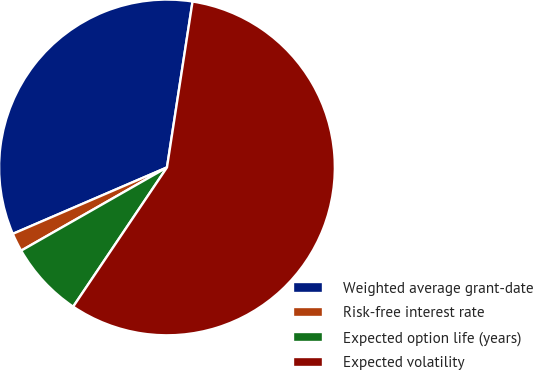Convert chart to OTSL. <chart><loc_0><loc_0><loc_500><loc_500><pie_chart><fcel>Weighted average grant-date<fcel>Risk-free interest rate<fcel>Expected option life (years)<fcel>Expected volatility<nl><fcel>33.91%<fcel>1.78%<fcel>7.31%<fcel>57.0%<nl></chart> 